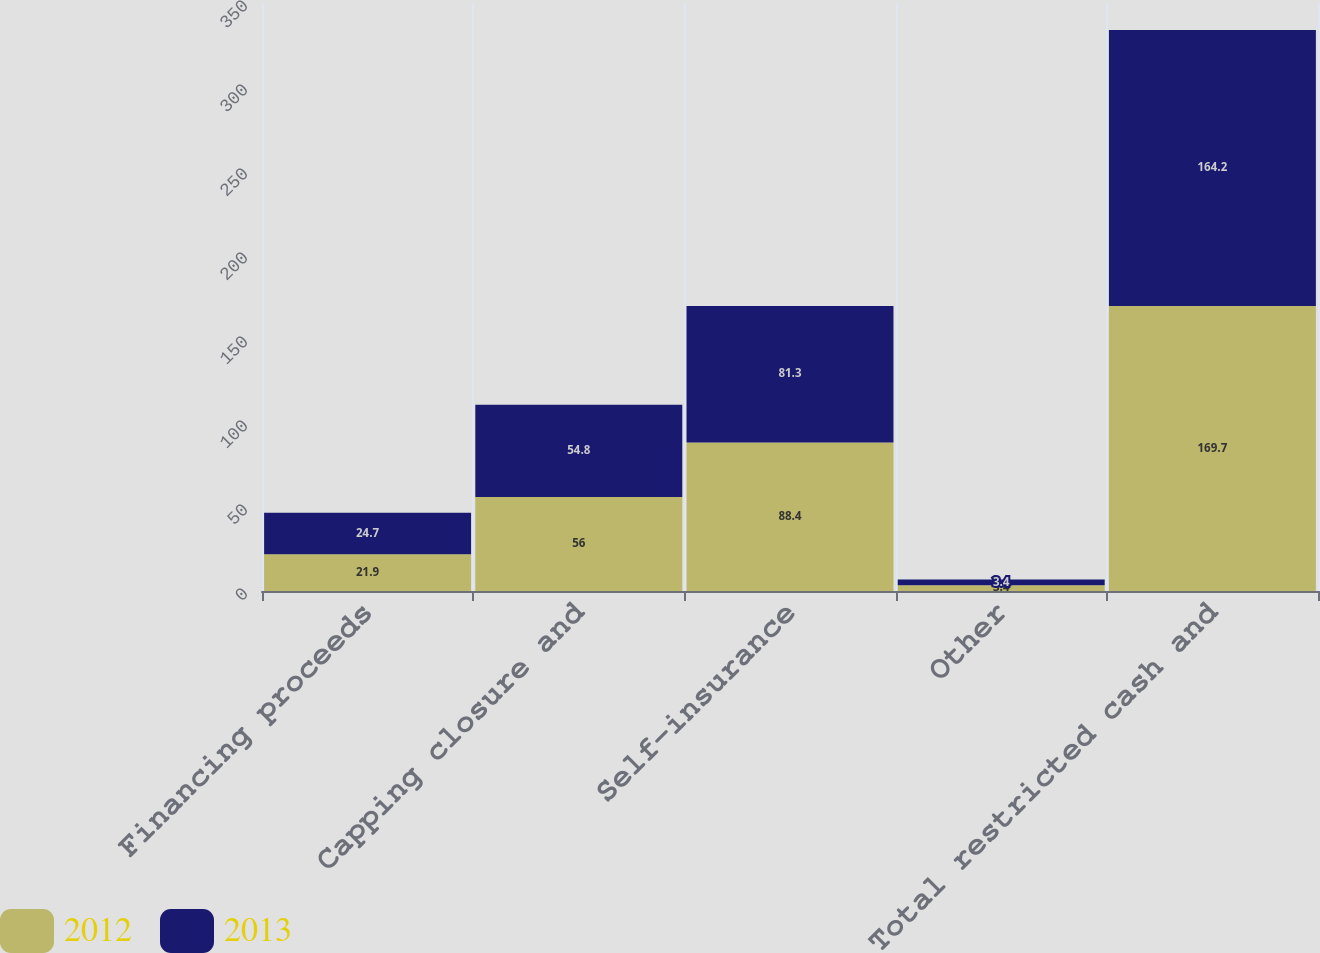<chart> <loc_0><loc_0><loc_500><loc_500><stacked_bar_chart><ecel><fcel>Financing proceeds<fcel>Capping closure and<fcel>Self-insurance<fcel>Other<fcel>Total restricted cash and<nl><fcel>2012<fcel>21.9<fcel>56<fcel>88.4<fcel>3.4<fcel>169.7<nl><fcel>2013<fcel>24.7<fcel>54.8<fcel>81.3<fcel>3.4<fcel>164.2<nl></chart> 